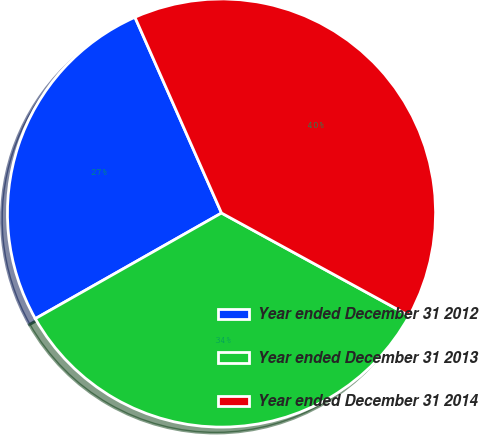Convert chart to OTSL. <chart><loc_0><loc_0><loc_500><loc_500><pie_chart><fcel>Year ended December 31 2012<fcel>Year ended December 31 2013<fcel>Year ended December 31 2014<nl><fcel>26.59%<fcel>33.82%<fcel>39.6%<nl></chart> 